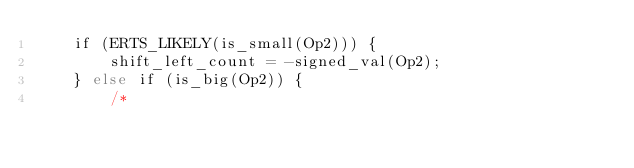Convert code to text. <code><loc_0><loc_0><loc_500><loc_500><_SQL_>    if (ERTS_LIKELY(is_small(Op2))) {
        shift_left_count = -signed_val(Op2);
    } else if (is_big(Op2)) {
        /*</code> 